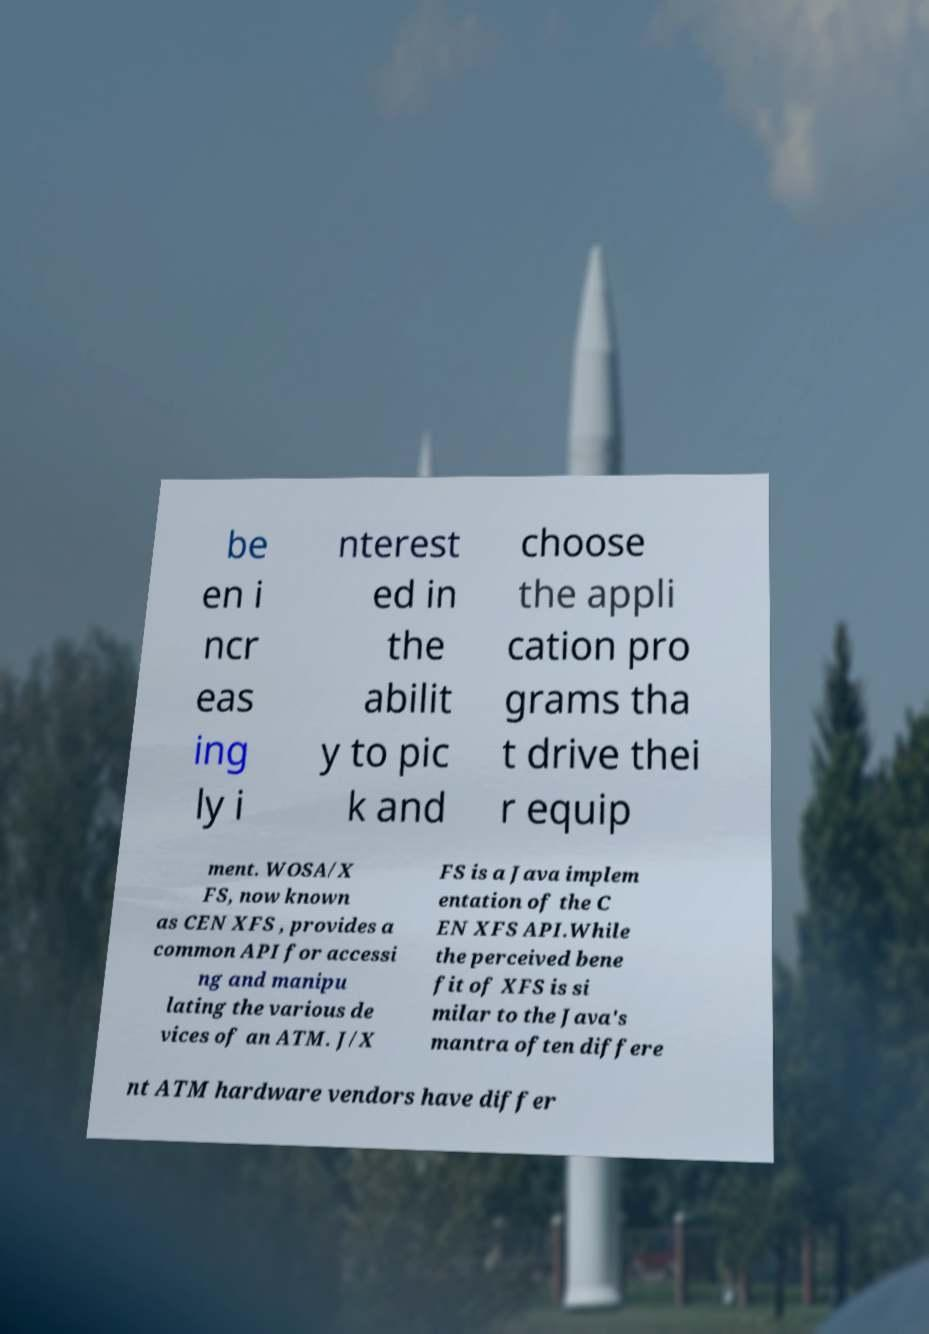For documentation purposes, I need the text within this image transcribed. Could you provide that? be en i ncr eas ing ly i nterest ed in the abilit y to pic k and choose the appli cation pro grams tha t drive thei r equip ment. WOSA/X FS, now known as CEN XFS , provides a common API for accessi ng and manipu lating the various de vices of an ATM. J/X FS is a Java implem entation of the C EN XFS API.While the perceived bene fit of XFS is si milar to the Java's mantra often differe nt ATM hardware vendors have differ 